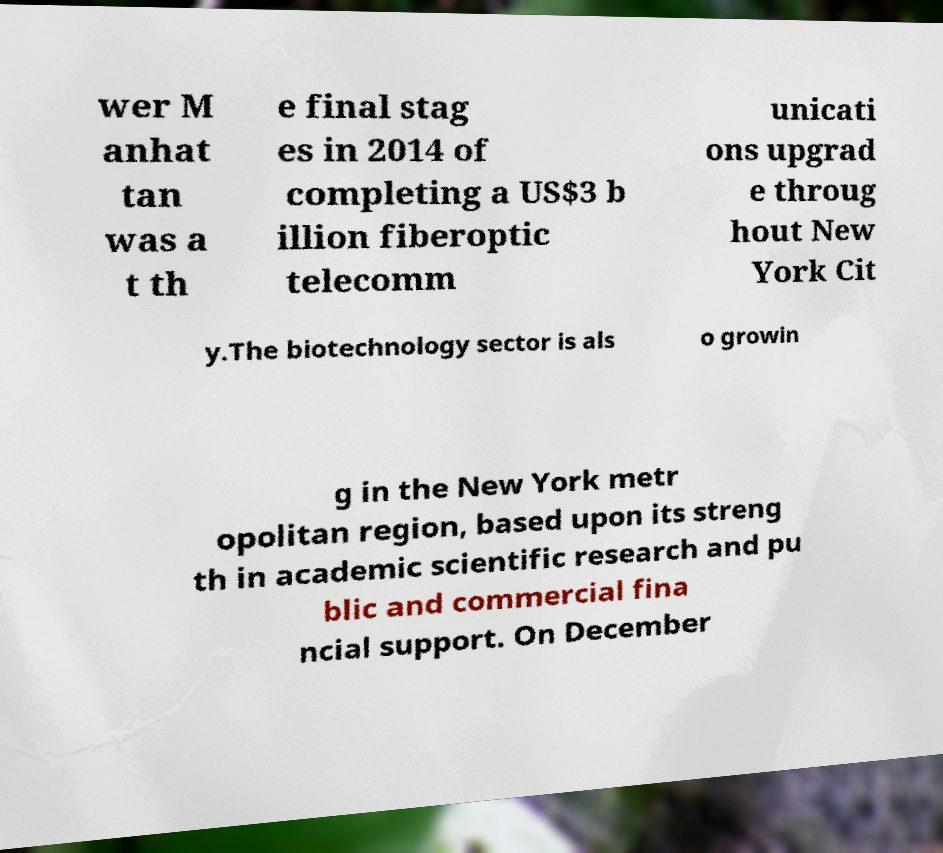Can you accurately transcribe the text from the provided image for me? wer M anhat tan was a t th e final stag es in 2014 of completing a US$3 b illion fiberoptic telecomm unicati ons upgrad e throug hout New York Cit y.The biotechnology sector is als o growin g in the New York metr opolitan region, based upon its streng th in academic scientific research and pu blic and commercial fina ncial support. On December 